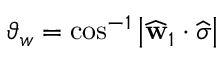<formula> <loc_0><loc_0><loc_500><loc_500>\vartheta _ { w } = \cos ^ { - 1 } \left | \widehat { w } _ { 1 } \cdot \widehat { \sigma } \right |</formula> 